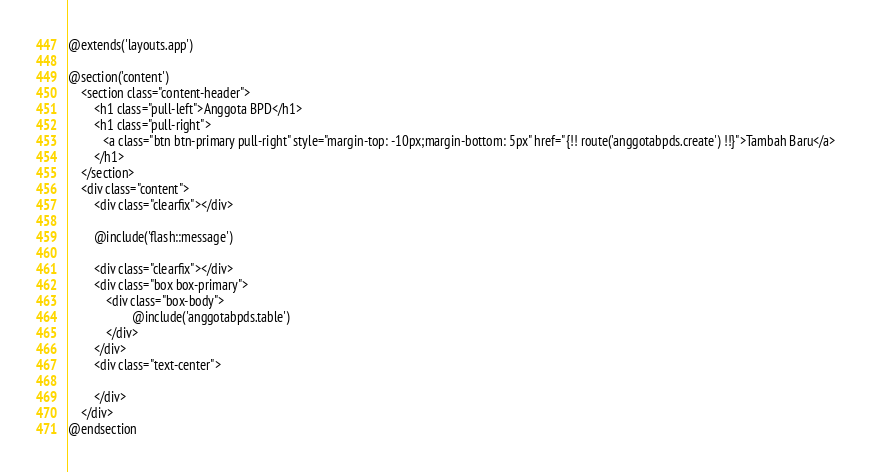Convert code to text. <code><loc_0><loc_0><loc_500><loc_500><_PHP_>@extends('layouts.app')

@section('content')
    <section class="content-header">
        <h1 class="pull-left">Anggota BPD</h1>
        <h1 class="pull-right">
           <a class="btn btn-primary pull-right" style="margin-top: -10px;margin-bottom: 5px" href="{!! route('anggotabpds.create') !!}">Tambah Baru</a>
        </h1>
    </section>
    <div class="content">
        <div class="clearfix"></div>

        @include('flash::message')

        <div class="clearfix"></div>
        <div class="box box-primary">
            <div class="box-body">
                    @include('anggotabpds.table')
            </div>
        </div>
        <div class="text-center">
        
        </div>
    </div>
@endsection

</code> 